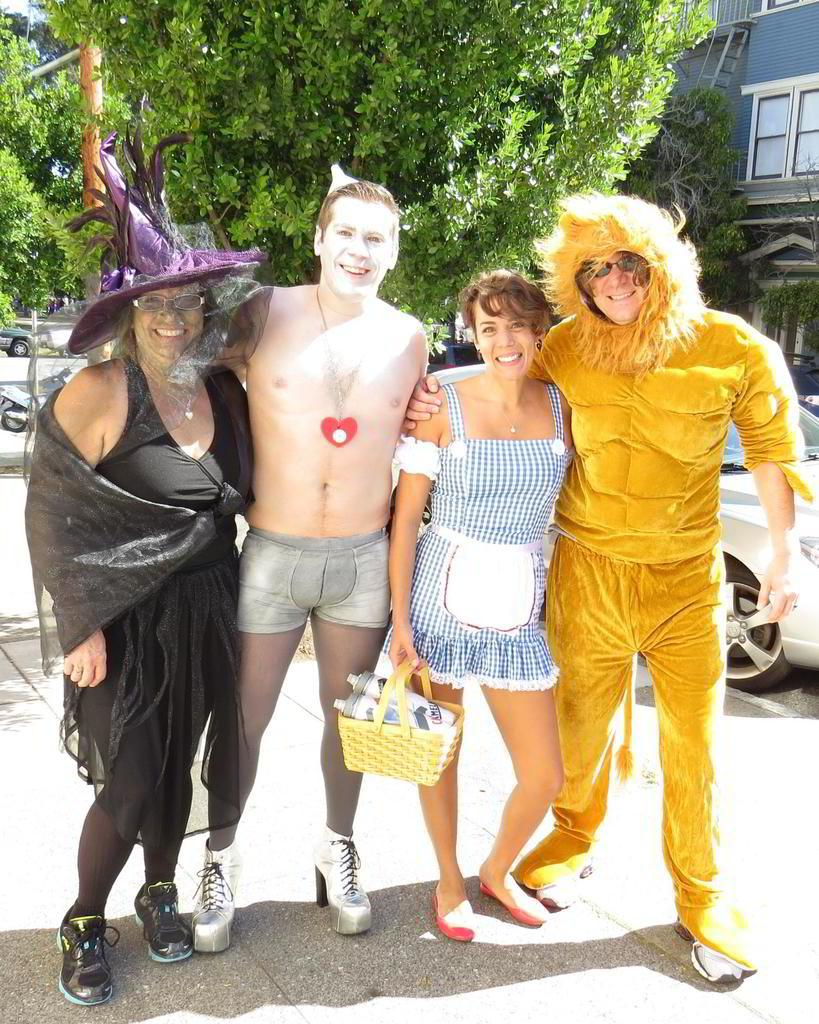What are the people in the image doing? The persons in the image are standing on the road. What can be seen in the background of the image? There are trees, a car, at least one building, and another vehicle in the background of the image. What time of day is the idea of the grandfather being discussed in the image? There is no mention of time, idea, or grandfather in the image, so it cannot be determined from the image. 